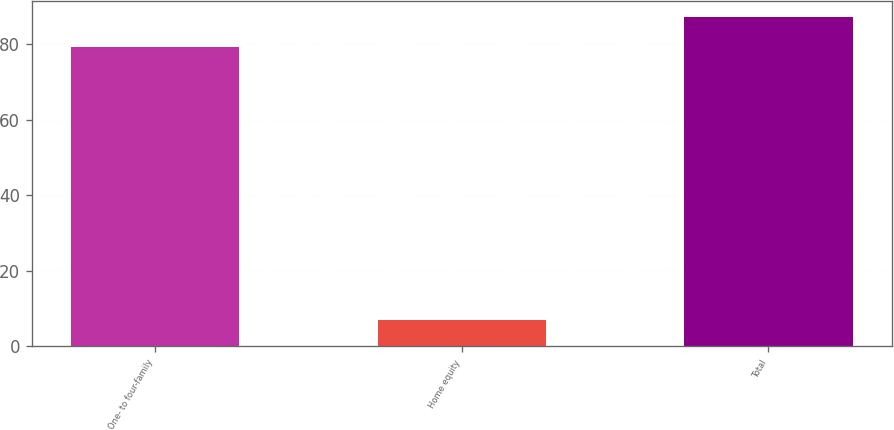<chart> <loc_0><loc_0><loc_500><loc_500><bar_chart><fcel>One- to four-family<fcel>Home equity<fcel>Total<nl><fcel>79.1<fcel>7.1<fcel>87.01<nl></chart> 